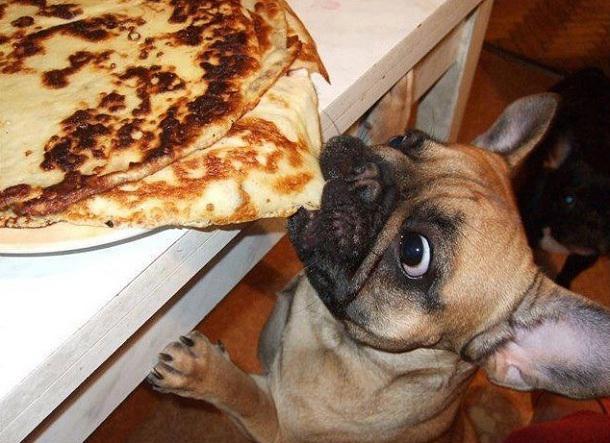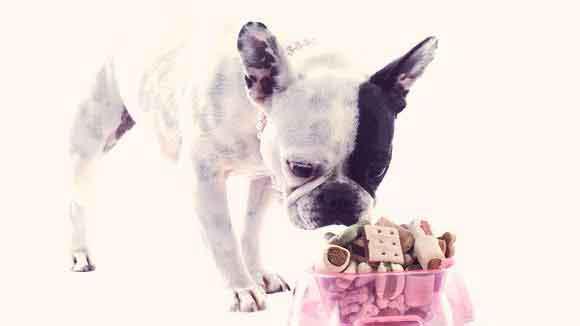The first image is the image on the left, the second image is the image on the right. Evaluate the accuracy of this statement regarding the images: "One dog is wearing a bib.". Is it true? Answer yes or no. No. The first image is the image on the left, the second image is the image on the right. Evaluate the accuracy of this statement regarding the images: "There is a dog sitting in a pile of dog treats.". Is it true? Answer yes or no. No. 